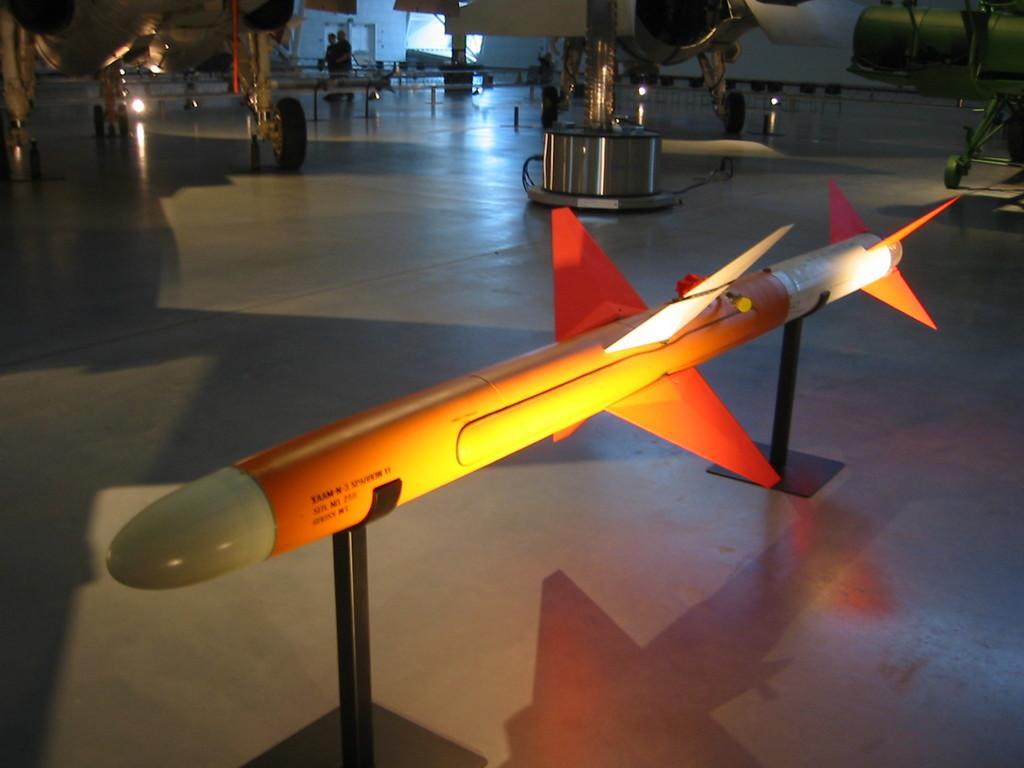Could you give a brief overview of what you see in this image? In the picture I can see a rocket missile on a black color object. In the background I can see airplanes, people standing on the floor and some other objects. 